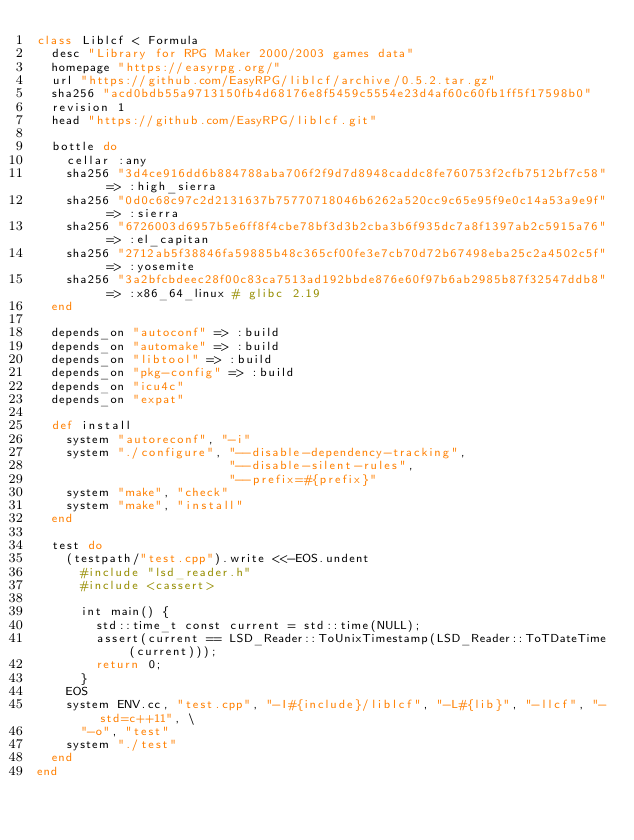<code> <loc_0><loc_0><loc_500><loc_500><_Ruby_>class Liblcf < Formula
  desc "Library for RPG Maker 2000/2003 games data"
  homepage "https://easyrpg.org/"
  url "https://github.com/EasyRPG/liblcf/archive/0.5.2.tar.gz"
  sha256 "acd0bdb55a9713150fb4d68176e8f5459c5554e23d4af60c60fb1ff5f17598b0"
  revision 1
  head "https://github.com/EasyRPG/liblcf.git"

  bottle do
    cellar :any
    sha256 "3d4ce916dd6b884788aba706f2f9d7d8948caddc8fe760753f2cfb7512bf7c58" => :high_sierra
    sha256 "0d0c68c97c2d2131637b75770718046b6262a520cc9c65e95f9e0c14a53a9e9f" => :sierra
    sha256 "6726003d6957b5e6ff8f4cbe78bf3d3b2cba3b6f935dc7a8f1397ab2c5915a76" => :el_capitan
    sha256 "2712ab5f38846fa59885b48c365cf00fe3e7cb70d72b67498eba25c2a4502c5f" => :yosemite
    sha256 "3a2bfcbdeec28f00c83ca7513ad192bbde876e60f97b6ab2985b87f32547ddb8" => :x86_64_linux # glibc 2.19
  end

  depends_on "autoconf" => :build
  depends_on "automake" => :build
  depends_on "libtool" => :build
  depends_on "pkg-config" => :build
  depends_on "icu4c"
  depends_on "expat"

  def install
    system "autoreconf", "-i"
    system "./configure", "--disable-dependency-tracking",
                          "--disable-silent-rules",
                          "--prefix=#{prefix}"
    system "make", "check"
    system "make", "install"
  end

  test do
    (testpath/"test.cpp").write <<-EOS.undent
      #include "lsd_reader.h"
      #include <cassert>

      int main() {
        std::time_t const current = std::time(NULL);
        assert(current == LSD_Reader::ToUnixTimestamp(LSD_Reader::ToTDateTime(current)));
        return 0;
      }
    EOS
    system ENV.cc, "test.cpp", "-I#{include}/liblcf", "-L#{lib}", "-llcf", "-std=c++11", \
      "-o", "test"
    system "./test"
  end
end
</code> 